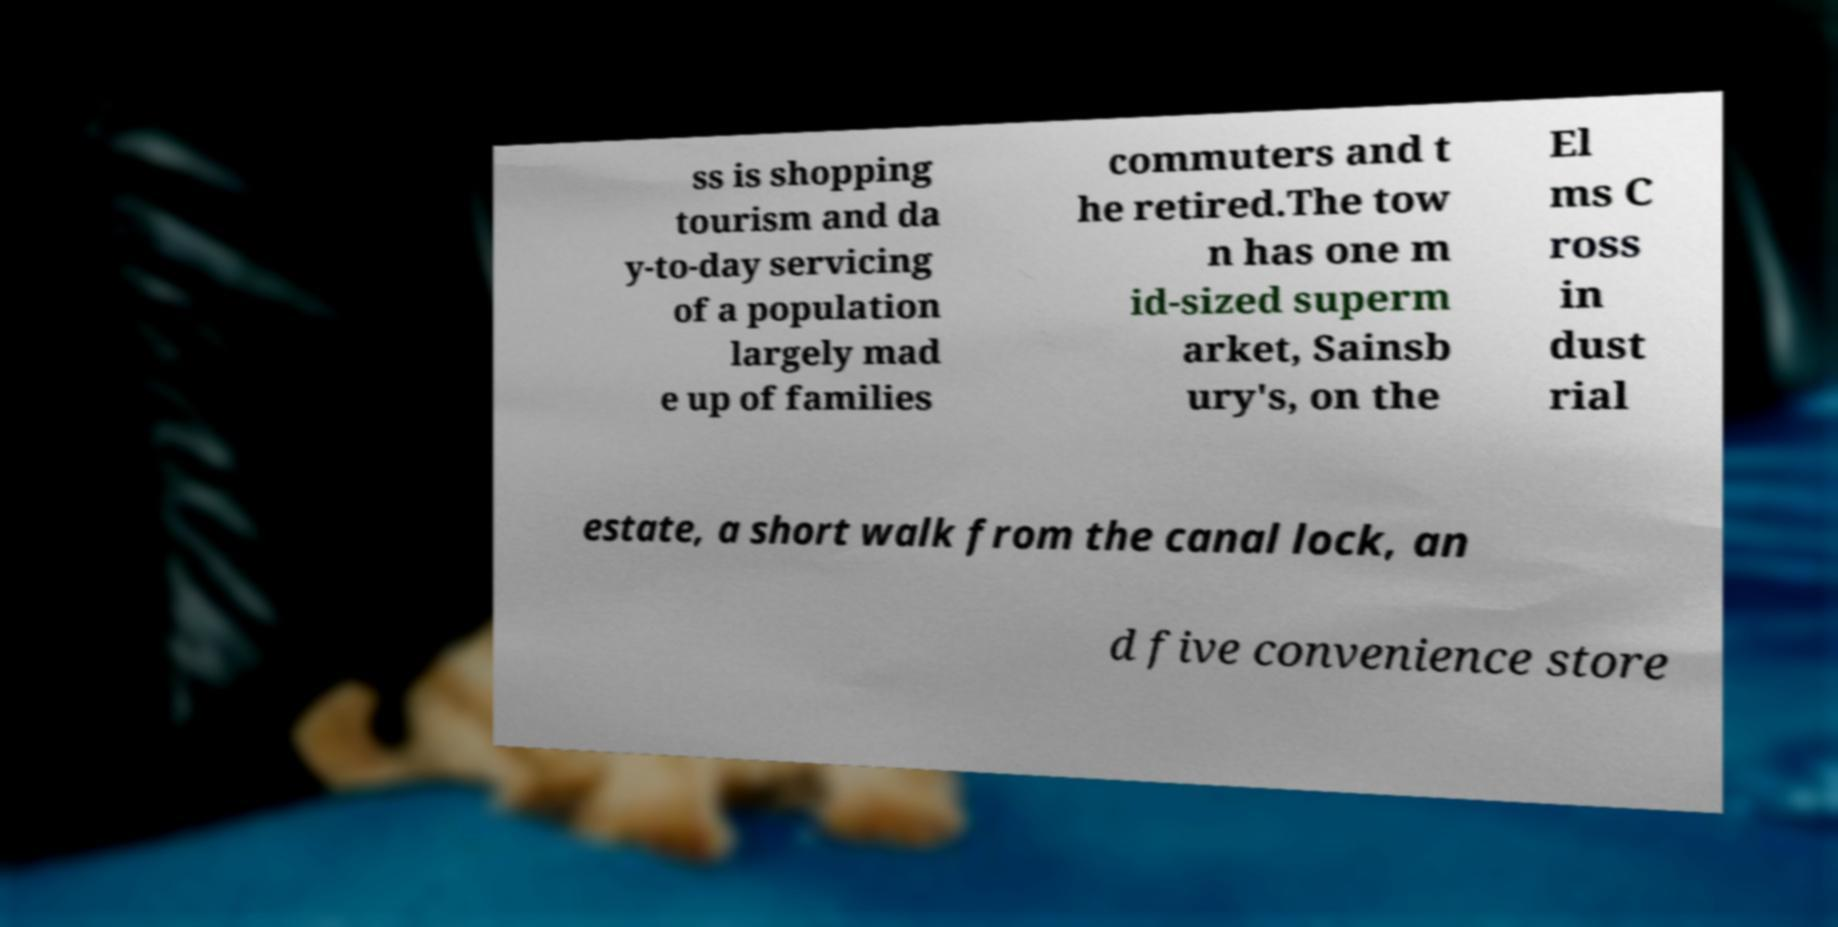For documentation purposes, I need the text within this image transcribed. Could you provide that? ss is shopping tourism and da y-to-day servicing of a population largely mad e up of families commuters and t he retired.The tow n has one m id-sized superm arket, Sainsb ury's, on the El ms C ross in dust rial estate, a short walk from the canal lock, an d five convenience store 